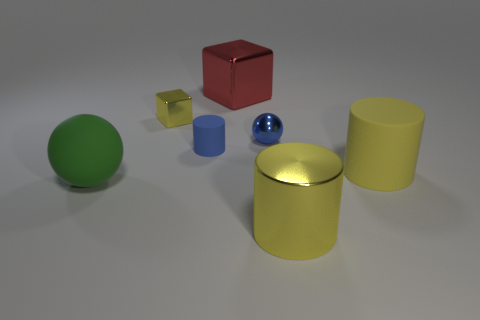What color is the big block that is the same material as the small block?
Provide a short and direct response. Red. What is the color of the big thing that is behind the big cylinder behind the matte sphere?
Make the answer very short. Red. Are there any big blocks of the same color as the tiny ball?
Make the answer very short. No. What is the shape of the red shiny thing that is the same size as the green object?
Your answer should be very brief. Cube. What number of yellow matte objects are behind the tiny blue shiny sphere on the right side of the red shiny object?
Make the answer very short. 0. Does the large matte sphere have the same color as the tiny block?
Ensure brevity in your answer.  No. How many other things are there of the same material as the green thing?
Give a very brief answer. 2. There is a large yellow matte thing that is right of the large metallic object that is in front of the red cube; what shape is it?
Your response must be concise. Cylinder. How big is the yellow cylinder in front of the green matte sphere?
Your response must be concise. Large. Do the tiny cylinder and the small yellow thing have the same material?
Ensure brevity in your answer.  No. 